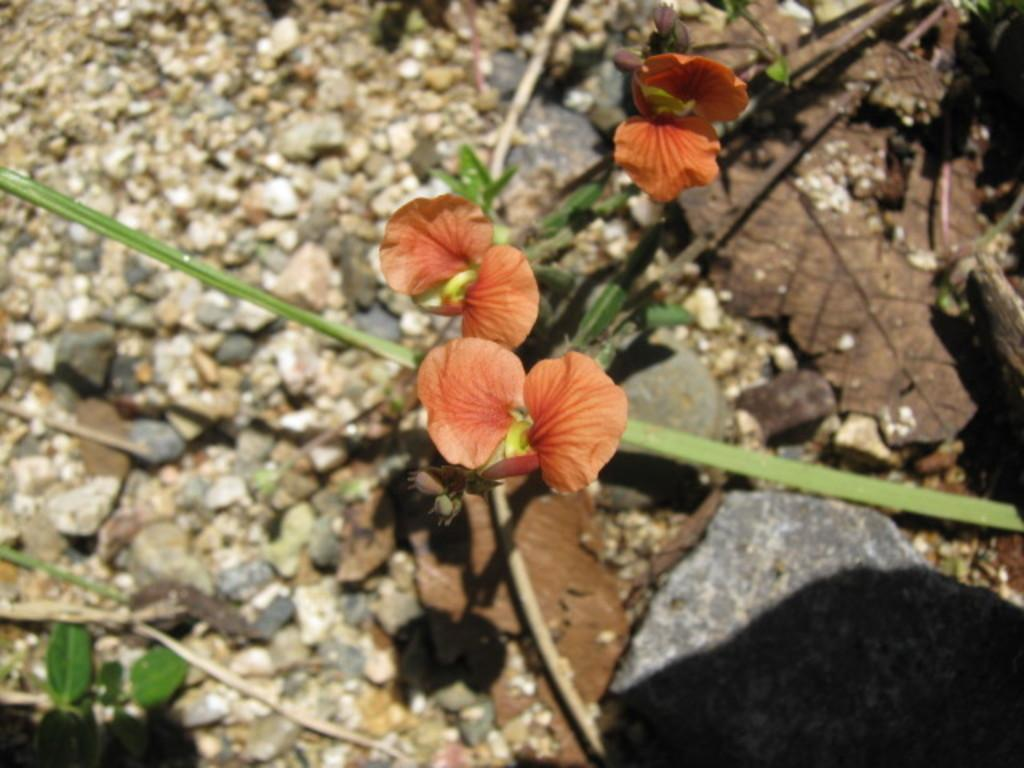What is the main subject of the image? There is a flower in the image. Can you describe the flower in more detail? The flower has a stem. What can be seen in the background of the image? There are stones in the background of the image. How does the flower adjust its petals in the image? The flower does not adjust its petals in the image; it is a still image and the flower's petals remain in the same position. 